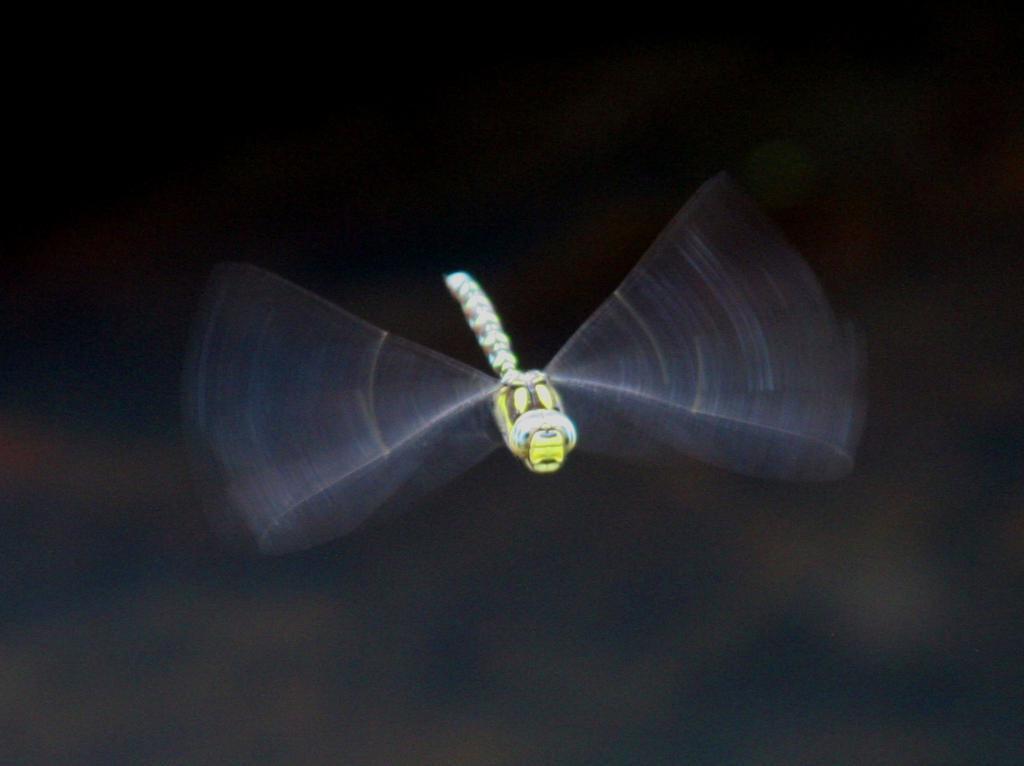Could you give a brief overview of what you see in this image? In this picture we can see a dragonfly and behind the dragonfly there is the blurred background. 